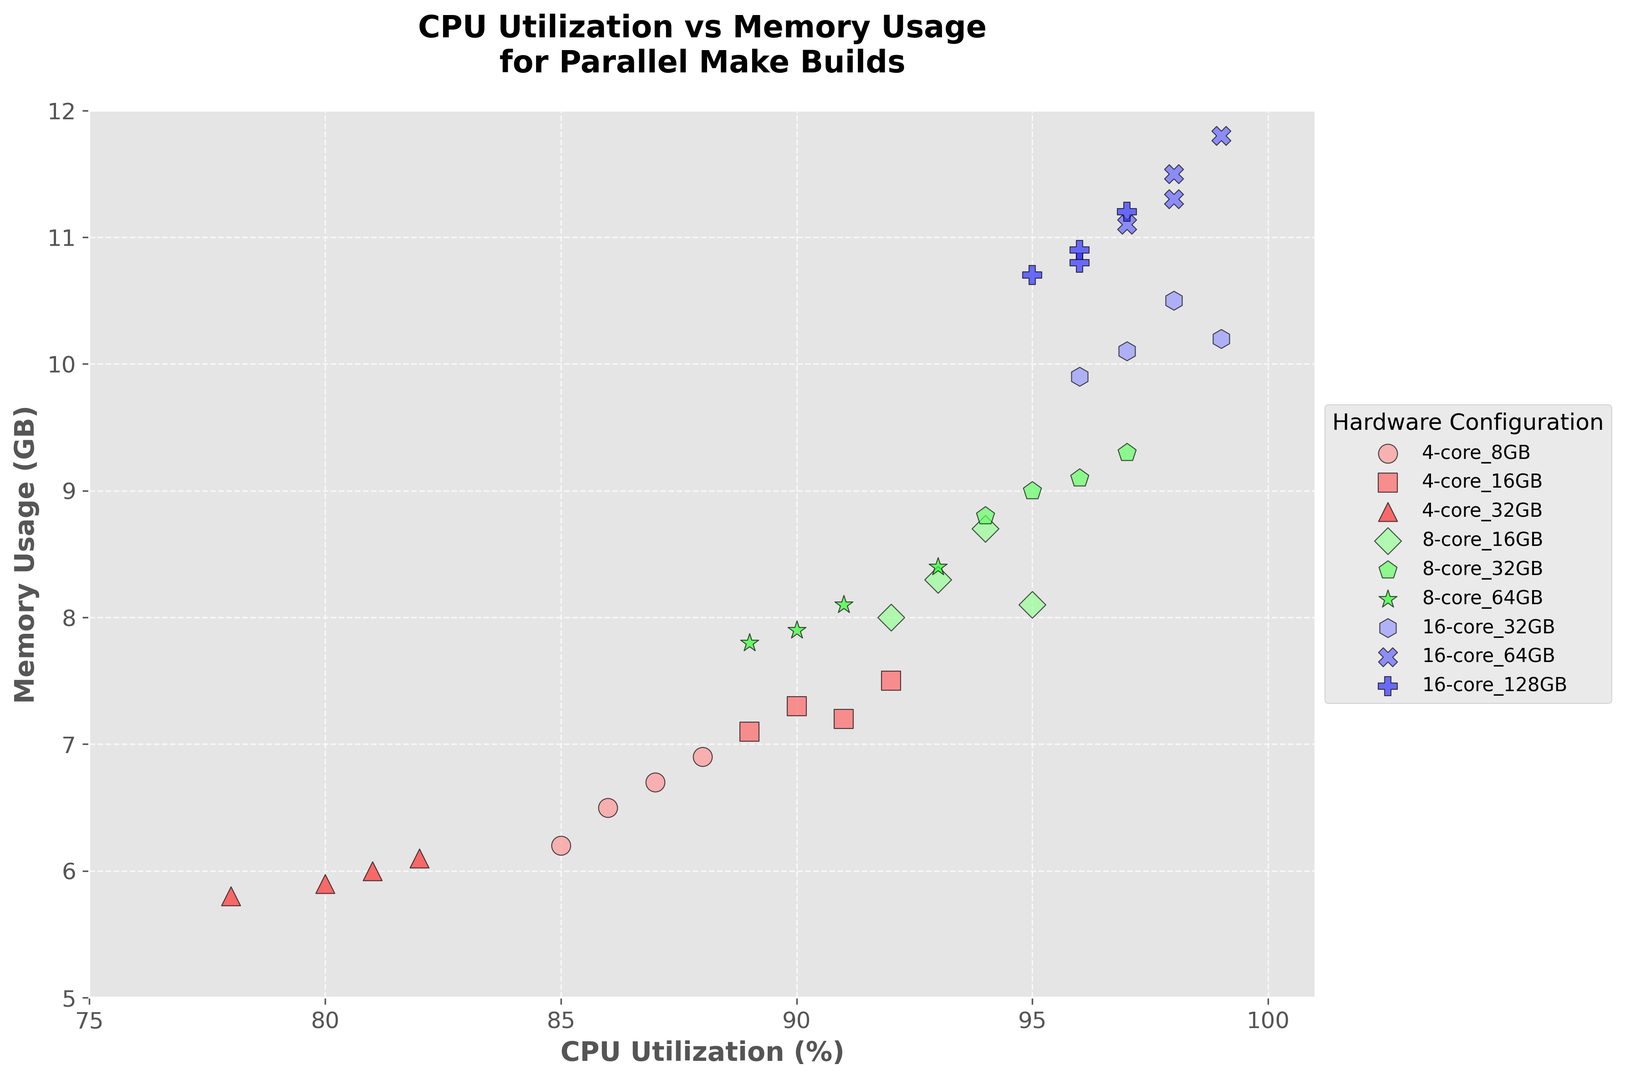What is the range of CPU utilization for systems with 16-core processors? To find the range of CPU utilization for systems with 16-core processors, we identify the minimum and maximum CPU utilization values within this group. The minimum is 96% and the maximum is 99%. Therefore, the range is from 96% to 99%.
Answer: 96% to 99% Which hardware configuration has the highest memory usage? By visually inspecting the figure, we see that the highest memory usage point is at 11.8 GB, which corresponds to the 16-core 64GB configuration.
Answer: 16-core 64GB Among 8-core configurations, which one shows the highest CPU utilization? We review the points for 8-core configs and identify the maximum CPU utilization value, which is 97%. This value corresponds to the 8-core 32GB configuration.
Answer: 8-core 32GB Compare the average CPU utilization between 4-core 32GB and 8-core 16GB configurations. Which one is higher? To compare the average CPU utilization, we calculate the mean for each configuration. For 4-core 32GB: (78+82+80+81)/4 = 80.25%. For 8-core 16GB: (95+94+93+92)/4 = 93.5%. Clearly, the 8-core 16GB has a higher average CPU utilization.
Answer: 8-core 16GB For 16-core 128GB, what is the average memory usage? The memory usage values for 16-core 128GB are 10.8, 11.2, and 10.9 GB. We sum and divide by 3: (10.8 + 11.2 + 10.9) / 3 = 10.97 GB.
Answer: 10.97 GB Which configuration shows the lowest CPU utilization and what is the corresponding memory usage? Reviewing the scatter plot, the lowest CPU utilization is 78%, which corresponds to the 4-core 32GB configuration with a memory usage of 5.8 GB.
Answer: 4-core 32GB, 5.8 GB What is the median memory usage for systems with 8-core processors? The memory usage values for 8-core configurations are 8.1, 9.3, 7.8, 8.7, 9.1, 8.4, 8.3, 9.0, 8.8, 7.9. To find the median, we sort the data: 7.8, 7.9, 8.1, 8.3, 8.4, 8.7, 8.8, 9.0, 9.1, 9.3. The median value (average of 5th and 6th) is (8.4 + 8.7) / 2 = 8.55 GB.
Answer: 8.55 GB Between 4-core 16GB and 8-core 64GB configurations, which shows a higher variability in memory usage? To determine variability, estimate the spread. 4-core 16GB has memory usage values 7.5, 7.2, 7.3, 7.1. The range is 7.5 - 7.1 = 0.4 GB. 8-core 64GB has 7.8, 8.4, 8.1, 7.9. The range is 8.4 - 7.8 = 0.6 GB. Thus, 8-core 64GB shows higher variability in memory usage.
Answer: 8-core 64GB How does the memory usage trend with increasing CPU cores from 4-core to 16-core, considering the highest memory configurations for each? From the figure, the highest memory usage in 4-core varies around 6 GB, 8-core around 9 GB, and 16-core around 11.5 GB. Memory usage increases with the number of CPU cores.
Answer: Increases Which configuration shows the most balanced CPU utilization and memory usage? Balanced utilization can be considered as having values close to each other in percentage. Visually, the 16-core 32GB configuration with values around 98% CPU utilization and 10.5 GB memory usage appears balanced.
Answer: 16-core 32GB 